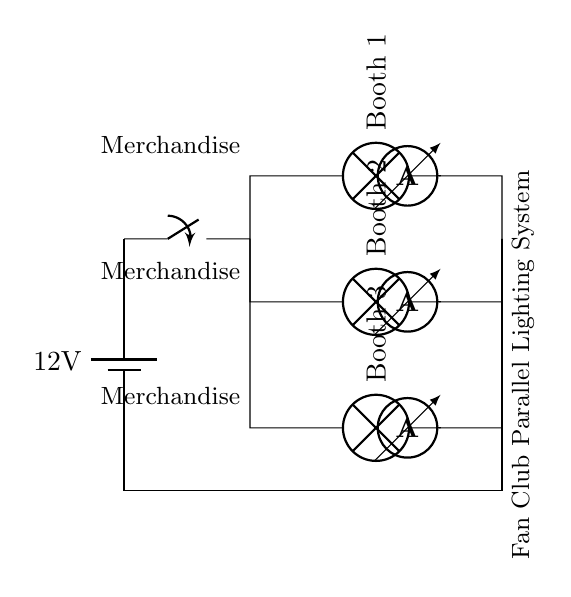What is the voltage of the battery? The battery provides a potential difference of 12 volts, as indicated in the circuit diagram.
Answer: 12 volts What components illuminate the merchandise booths? The circuit shows three lamps in parallel, which are directly connected to the power source to illuminate the merchandise booths.
Answer: Lamps How many booths are illuminated in this circuit? There are three booths illustrated in the circuit, each represented by a separate lamp connected in parallel.
Answer: Three What is the role of the switch in this circuit? The switch serves as the main control device to turn the lighting system on or off, interrupting the connection between the battery and the lamps.
Answer: Control If one lamp fails, what happens to the others? In a parallel circuit, if one lamp fails, the other lamps will continue to receive power and function normally because they are independently connected to the power source.
Answer: Continue functioning What measurements are indicated in the circuit for each lamp? Each lamp has an ammeter connected to it, showing the current flow through each branch of the circuit.
Answer: Ammeter 